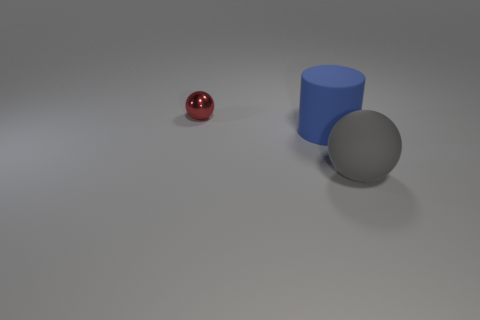Add 1 tiny purple rubber things. How many objects exist? 4 Subtract all spheres. How many objects are left? 1 Subtract 2 spheres. How many spheres are left? 0 Subtract all purple spheres. How many yellow cylinders are left? 0 Subtract all blue objects. Subtract all large gray matte things. How many objects are left? 1 Add 3 cylinders. How many cylinders are left? 4 Add 2 brown blocks. How many brown blocks exist? 2 Subtract 0 blue spheres. How many objects are left? 3 Subtract all cyan cylinders. Subtract all brown cubes. How many cylinders are left? 1 